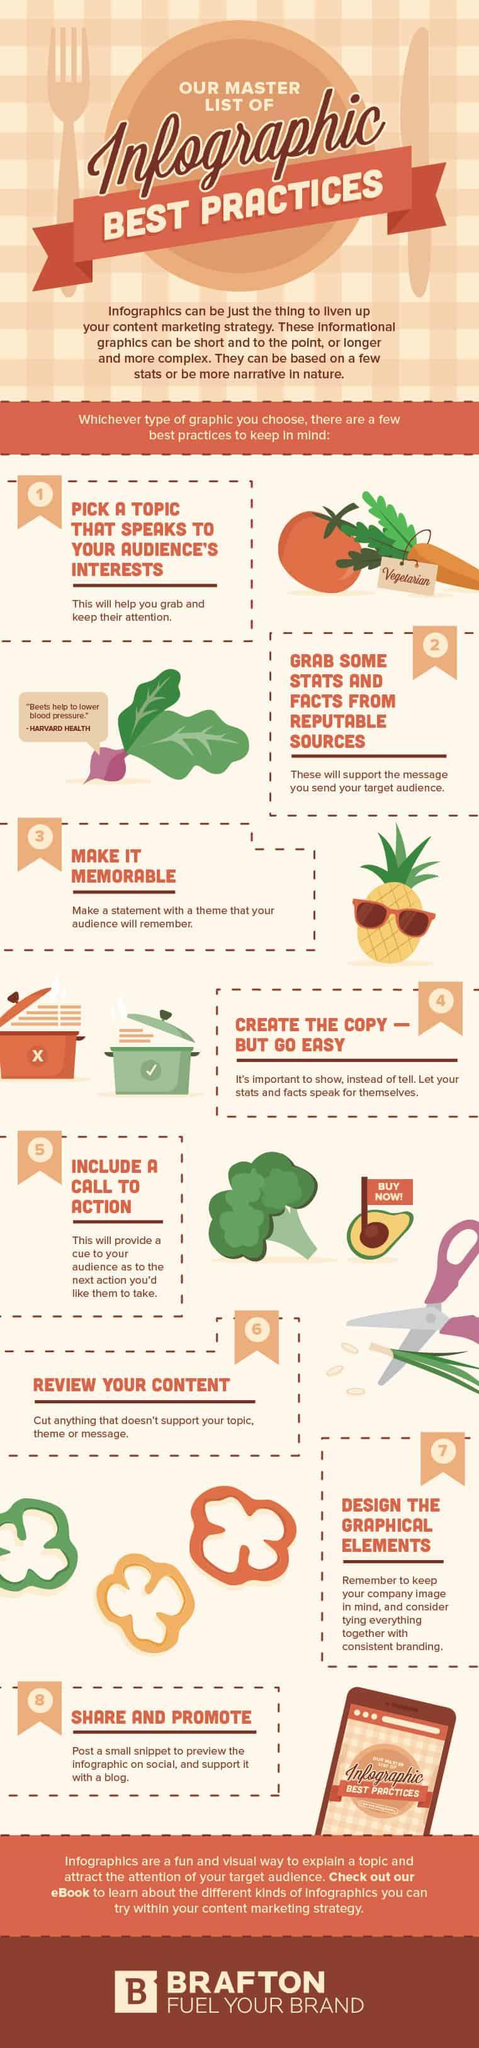On which fruit is a red flag placed, pineapple, avocado, or broccoli?
Answer the question with a short phrase. avocado Which vegetable helps in reducing BP, tomato, carrots, or beetroots? beetroots 